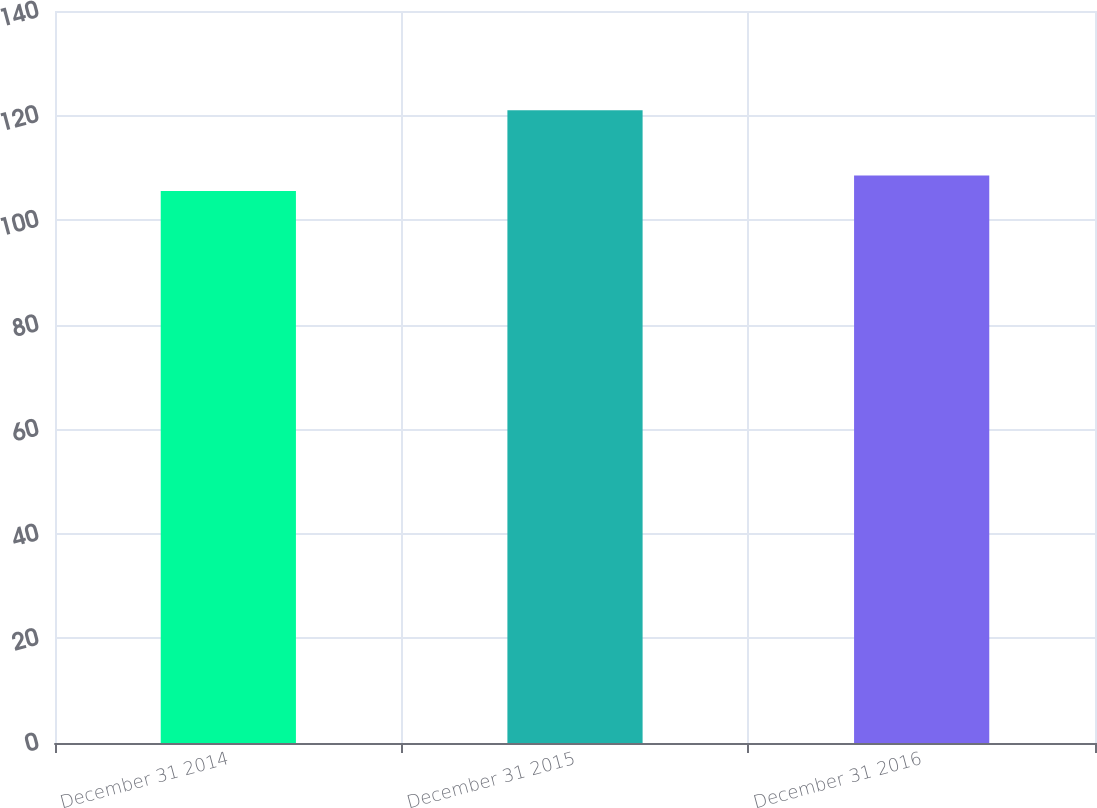Convert chart to OTSL. <chart><loc_0><loc_0><loc_500><loc_500><bar_chart><fcel>December 31 2014<fcel>December 31 2015<fcel>December 31 2016<nl><fcel>105.59<fcel>121.02<fcel>108.53<nl></chart> 